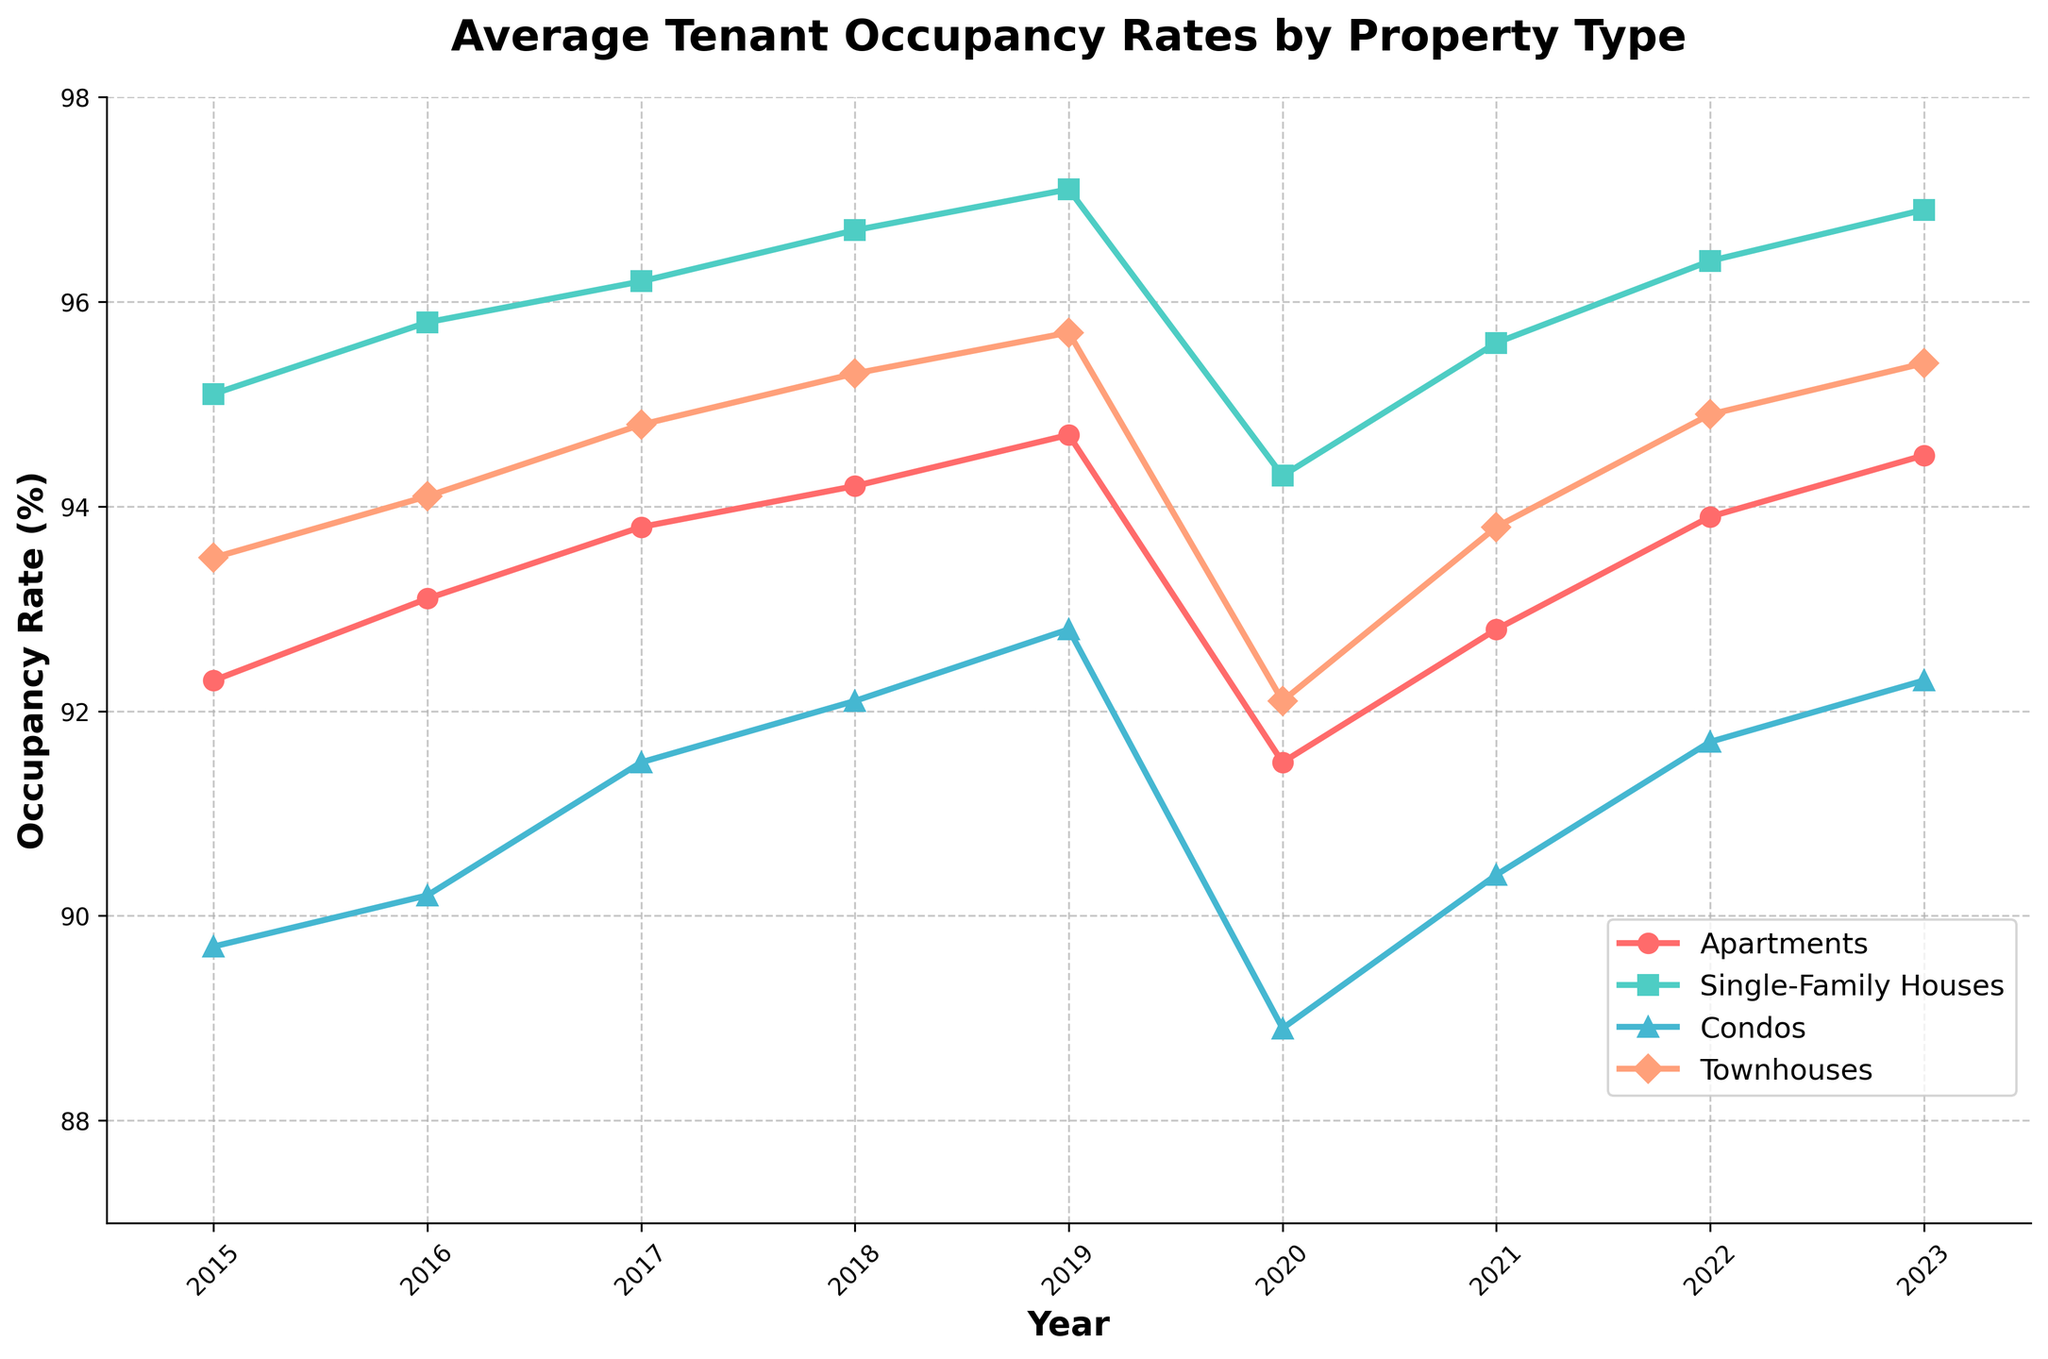What is the average occupancy rate of apartments over the whole period? To find the average occupancy rate of apartments from 2015 to 2023, sum the occupancy rates of apartments for each year and divide by the number of years. The sum is (92.3 + 93.1 + 93.8 + 94.2 + 94.7 + 91.5 + 92.8 + 93.9 + 94.5) = 830.8. There are 9 years, so the average is 830.8 / 9 ≈ 92.31
Answer: 92.31 Which property type had the highest occupancy rate in 2019? In 2019, the figure shows that apartments had an occupancy rate of 94.7, single-family houses had 97.1, condos had 92.8, and townhouses had 95.7. The highest among these is 97.1 for single-family houses
Answer: Single-Family Houses Did any property type experience a decrease in occupancy rate from 2019 to 2020? Comparing the occupancy rates from 2019 to 2020: apartments dropped from 94.7 to 91.5, single-family houses dropped from 97.1 to 94.3, condos dropped from 92.8 to 88.9, and townhouses dropped from 95.7 to 92.1. All property types experienced a decrease
Answer: Yes Between 2020 and 2023, which property type showed the most significant recovery in occupancy rate? Calculate the difference in occupancy rate between 2020 and 2023 for each property type. Apartments increased from 91.5 to 94.5 (3.0), single-family houses from 94.3 to 96.9 (2.6), condos from 88.9 to 92.3 (3.4), and townhouses from 92.1 to 95.4 (3.3). The largest recovery is for condos with an increase of 3.4
Answer: Condos What is the trend in occupancy rate of single-family houses over the years? Observing the figure, the occupancy rate for single-family houses has increased almost every year from 95.1 in 2015 to 97.1 in 2019, dropped to 94.3 in 2020, and then gradually increased to 96.9 in 2023
Answer: Increasing trend By how much did the occupancy rate of townhouses increase from 2015 to 2023? Subtract the occupancy rate of townhouses in 2015 from that in 2023. The occupancy rate in 2015 was 93.5, and in 2023 it was 95.4. The increase is 95.4 - 93.5 = 1.9
Answer: 1.9 Which property type had the lowest occupancy rate in 2020? In 2020, apartments had an occupancy rate of 91.5, single-family houses had 94.3, condos had 88.9, and townhouses had 92.1. The lowest among these is 88.9 for condos
Answer: Condos What is the range of occupancy rates for condos over the given period? The minimum occupancy rate for condos is observed in 2020 at 88.9, and the maximum is in 2019 at 92.8. The range is 92.8 - 88.9 = 3.9
Answer: 3.9 